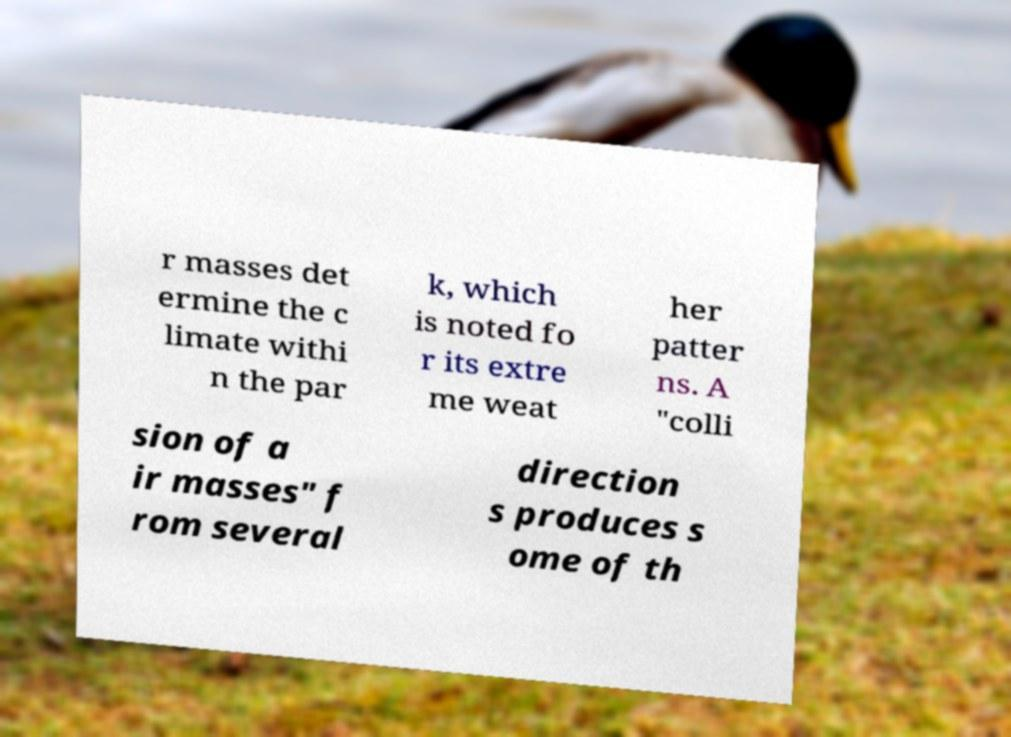There's text embedded in this image that I need extracted. Can you transcribe it verbatim? r masses det ermine the c limate withi n the par k, which is noted fo r its extre me weat her patter ns. A "colli sion of a ir masses" f rom several direction s produces s ome of th 